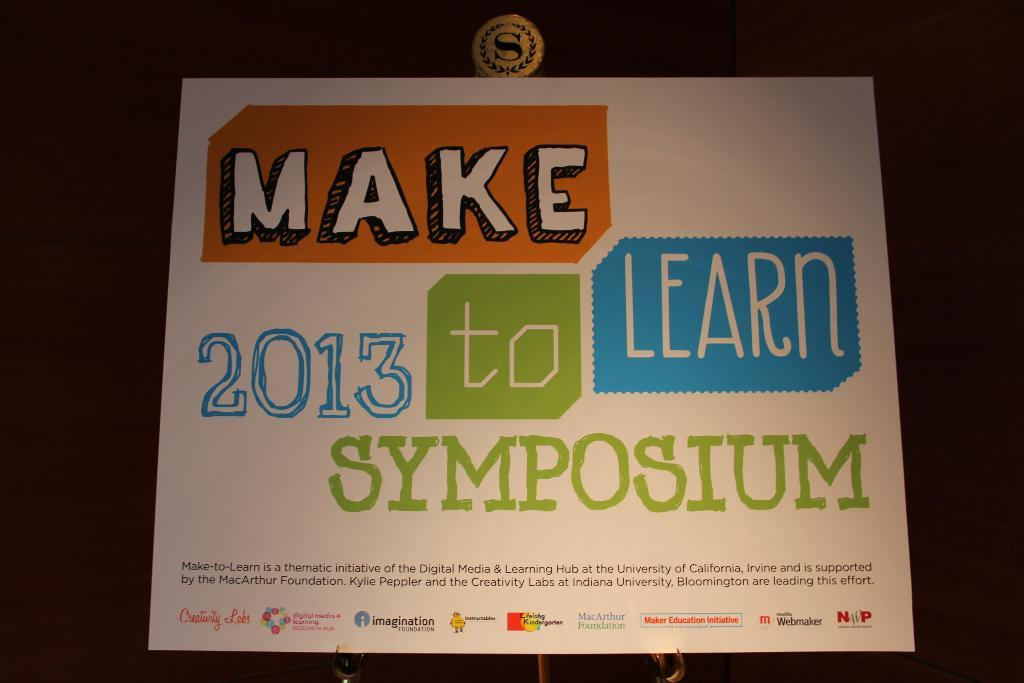<image>
Provide a brief description of the given image. A sign for a symposium is attached to a wall. 